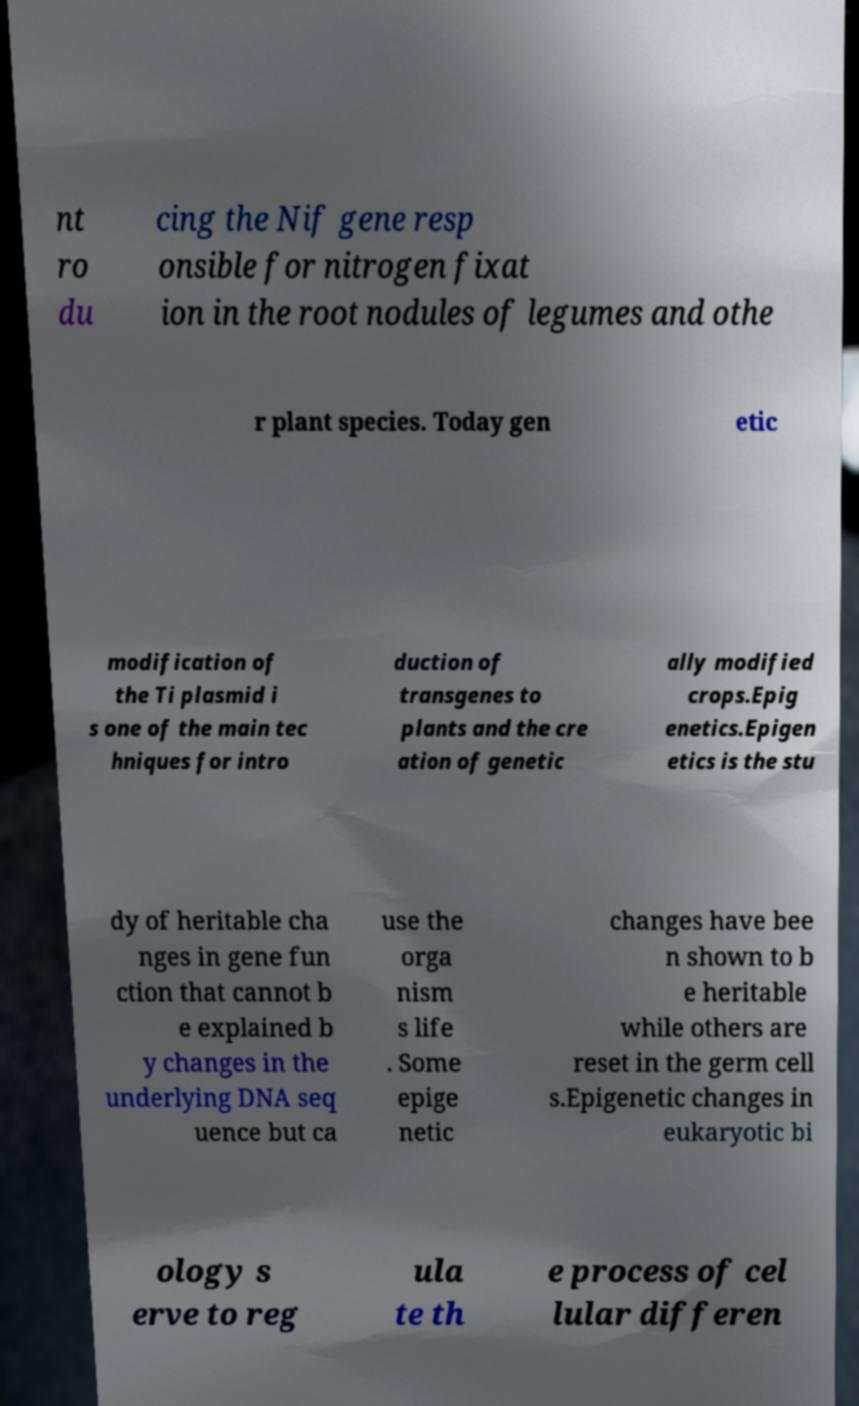There's text embedded in this image that I need extracted. Can you transcribe it verbatim? nt ro du cing the Nif gene resp onsible for nitrogen fixat ion in the root nodules of legumes and othe r plant species. Today gen etic modification of the Ti plasmid i s one of the main tec hniques for intro duction of transgenes to plants and the cre ation of genetic ally modified crops.Epig enetics.Epigen etics is the stu dy of heritable cha nges in gene fun ction that cannot b e explained b y changes in the underlying DNA seq uence but ca use the orga nism s life . Some epige netic changes have bee n shown to b e heritable while others are reset in the germ cell s.Epigenetic changes in eukaryotic bi ology s erve to reg ula te th e process of cel lular differen 